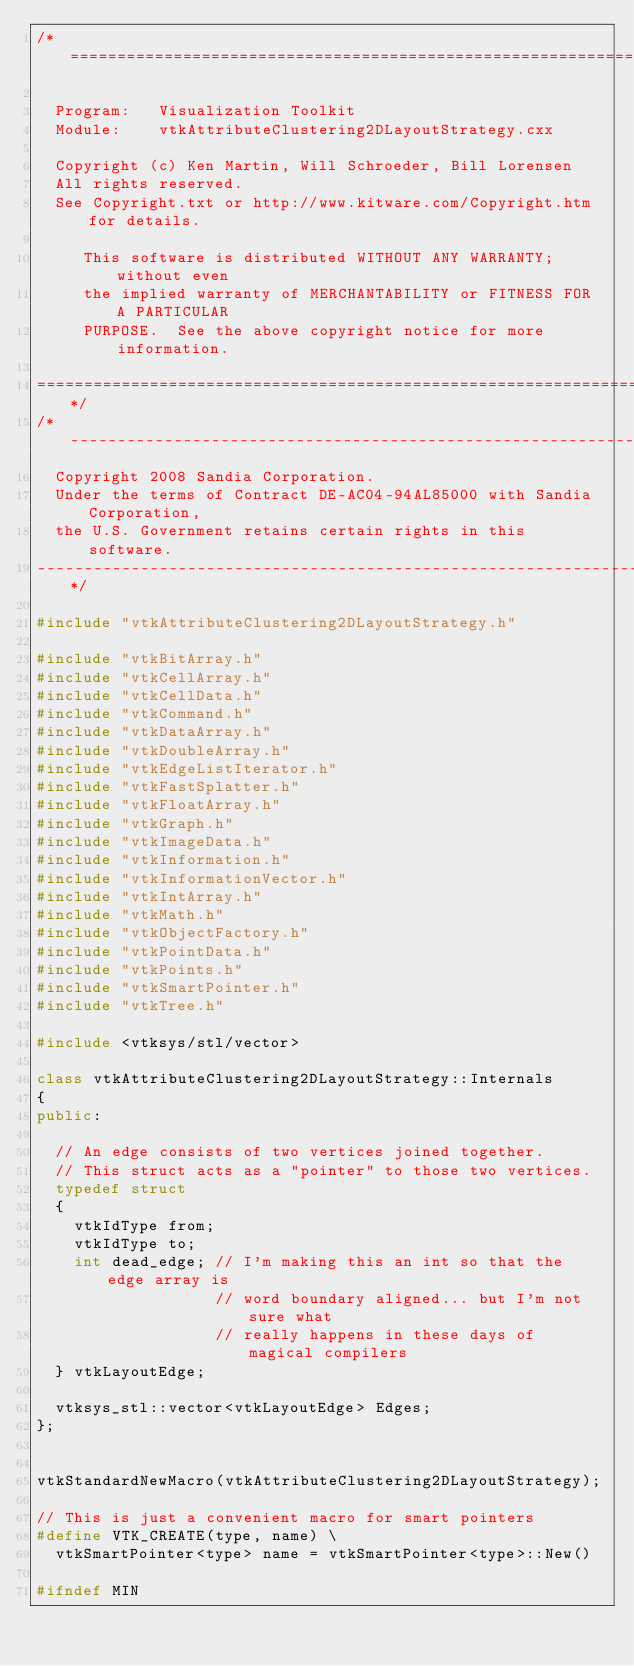Convert code to text. <code><loc_0><loc_0><loc_500><loc_500><_C++_>/*=========================================================================

  Program:   Visualization Toolkit
  Module:    vtkAttributeClustering2DLayoutStrategy.cxx

  Copyright (c) Ken Martin, Will Schroeder, Bill Lorensen
  All rights reserved.
  See Copyright.txt or http://www.kitware.com/Copyright.htm for details.

     This software is distributed WITHOUT ANY WARRANTY; without even
     the implied warranty of MERCHANTABILITY or FITNESS FOR A PARTICULAR
     PURPOSE.  See the above copyright notice for more information.

=========================================================================*/
/*-------------------------------------------------------------------------
  Copyright 2008 Sandia Corporation.
  Under the terms of Contract DE-AC04-94AL85000 with Sandia Corporation,
  the U.S. Government retains certain rights in this software.
-------------------------------------------------------------------------*/

#include "vtkAttributeClustering2DLayoutStrategy.h"

#include "vtkBitArray.h"
#include "vtkCellArray.h"
#include "vtkCellData.h"
#include "vtkCommand.h"
#include "vtkDataArray.h"
#include "vtkDoubleArray.h"
#include "vtkEdgeListIterator.h"
#include "vtkFastSplatter.h"
#include "vtkFloatArray.h"
#include "vtkGraph.h"
#include "vtkImageData.h"
#include "vtkInformation.h"
#include "vtkInformationVector.h"
#include "vtkIntArray.h"
#include "vtkMath.h"
#include "vtkObjectFactory.h"
#include "vtkPointData.h"
#include "vtkPoints.h"
#include "vtkSmartPointer.h"
#include "vtkTree.h"

#include <vtksys/stl/vector>

class vtkAttributeClustering2DLayoutStrategy::Internals
{
public:

  // An edge consists of two vertices joined together.
  // This struct acts as a "pointer" to those two vertices.
  typedef struct
  {
    vtkIdType from;
    vtkIdType to;
    int dead_edge; // I'm making this an int so that the edge array is
                   // word boundary aligned... but I'm not sure what
                   // really happens in these days of magical compilers
  } vtkLayoutEdge;

  vtksys_stl::vector<vtkLayoutEdge> Edges;
};


vtkStandardNewMacro(vtkAttributeClustering2DLayoutStrategy);

// This is just a convenient macro for smart pointers
#define VTK_CREATE(type, name) \
  vtkSmartPointer<type> name = vtkSmartPointer<type>::New()

#ifndef MIN</code> 